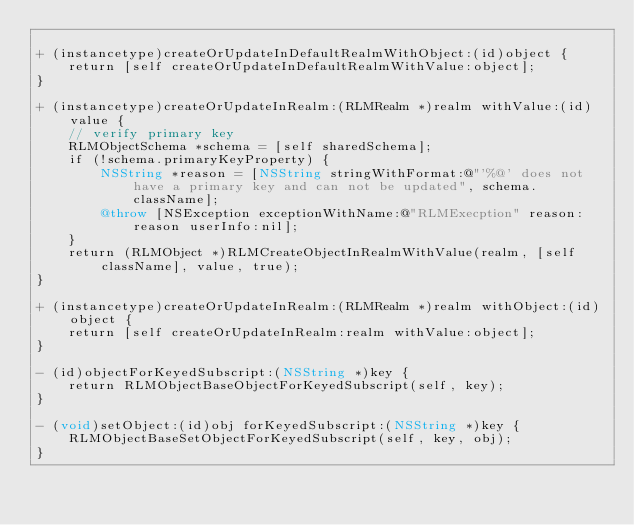<code> <loc_0><loc_0><loc_500><loc_500><_ObjectiveC_>
+ (instancetype)createOrUpdateInDefaultRealmWithObject:(id)object {
    return [self createOrUpdateInDefaultRealmWithValue:object];
}

+ (instancetype)createOrUpdateInRealm:(RLMRealm *)realm withValue:(id)value {
    // verify primary key
    RLMObjectSchema *schema = [self sharedSchema];
    if (!schema.primaryKeyProperty) {
        NSString *reason = [NSString stringWithFormat:@"'%@' does not have a primary key and can not be updated", schema.className];
        @throw [NSException exceptionWithName:@"RLMExecption" reason:reason userInfo:nil];
    }
    return (RLMObject *)RLMCreateObjectInRealmWithValue(realm, [self className], value, true);
}

+ (instancetype)createOrUpdateInRealm:(RLMRealm *)realm withObject:(id)object {
    return [self createOrUpdateInRealm:realm withValue:object];
}

- (id)objectForKeyedSubscript:(NSString *)key {
    return RLMObjectBaseObjectForKeyedSubscript(self, key);
}

- (void)setObject:(id)obj forKeyedSubscript:(NSString *)key {
    RLMObjectBaseSetObjectForKeyedSubscript(self, key, obj);
}
</code> 